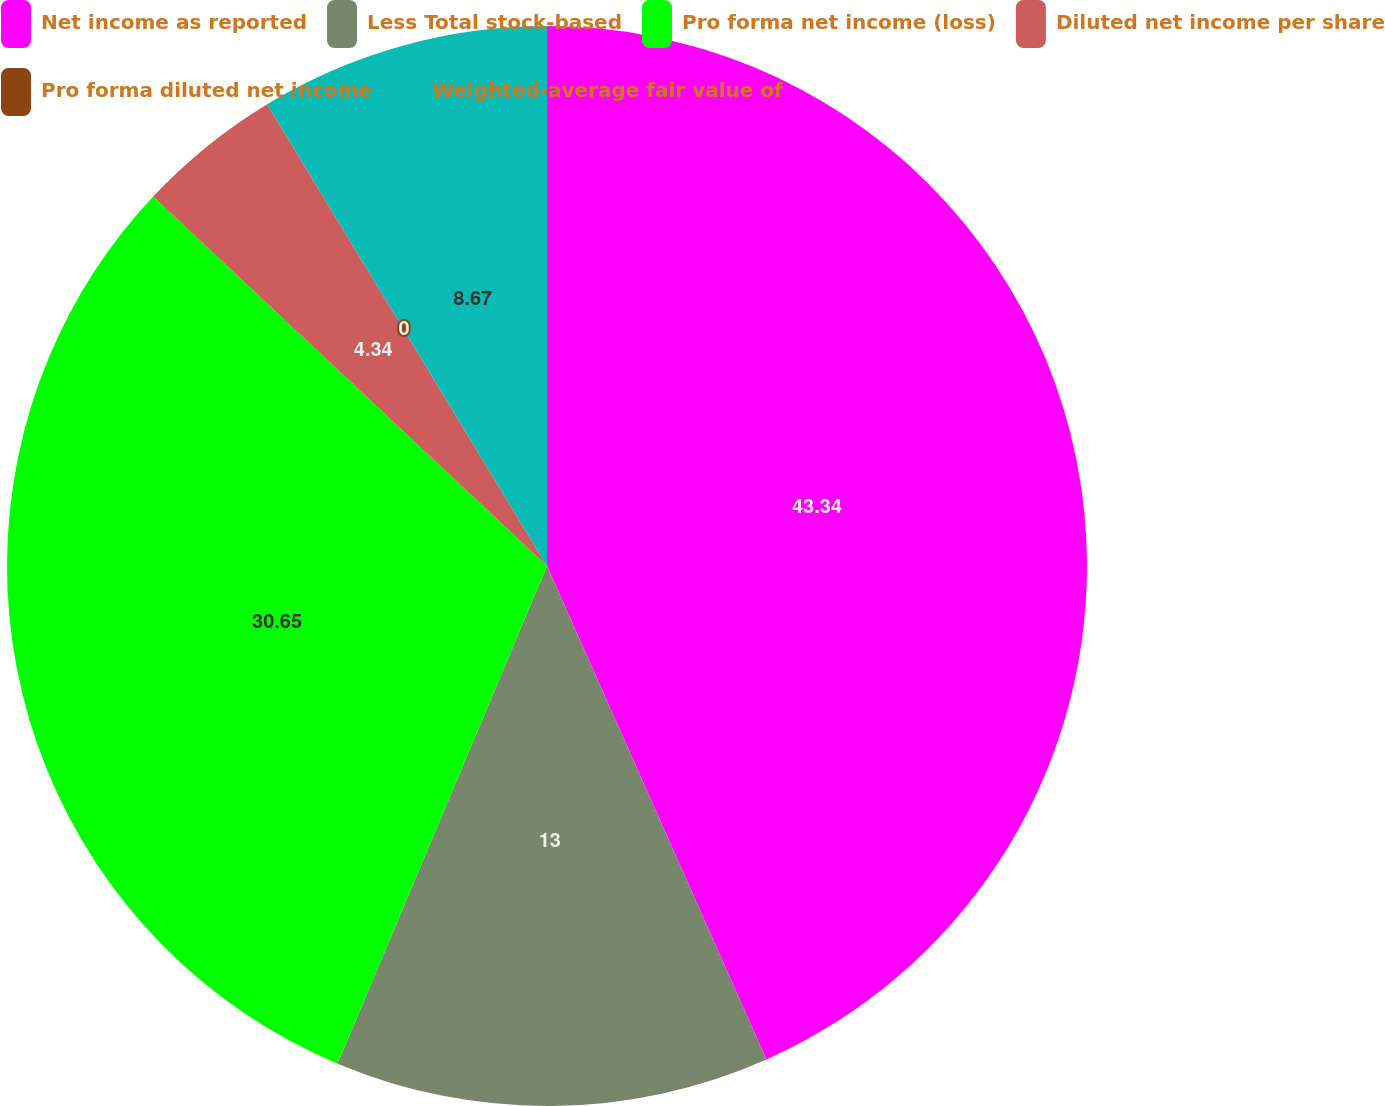Convert chart. <chart><loc_0><loc_0><loc_500><loc_500><pie_chart><fcel>Net income as reported<fcel>Less Total stock-based<fcel>Pro forma net income (loss)<fcel>Diluted net income per share<fcel>Pro forma diluted net income<fcel>Weighted-average fair value of<nl><fcel>43.34%<fcel>13.0%<fcel>30.65%<fcel>4.34%<fcel>0.0%<fcel>8.67%<nl></chart> 